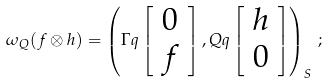Convert formula to latex. <formula><loc_0><loc_0><loc_500><loc_500>\omega _ { Q } ( f \otimes h ) = \left ( \Gamma q \left [ \begin{array} { c } 0 \\ f \end{array} \right ] , Q q \left [ \begin{array} { c } h \\ 0 \end{array} \right ] \right ) _ { S } \, ;</formula> 